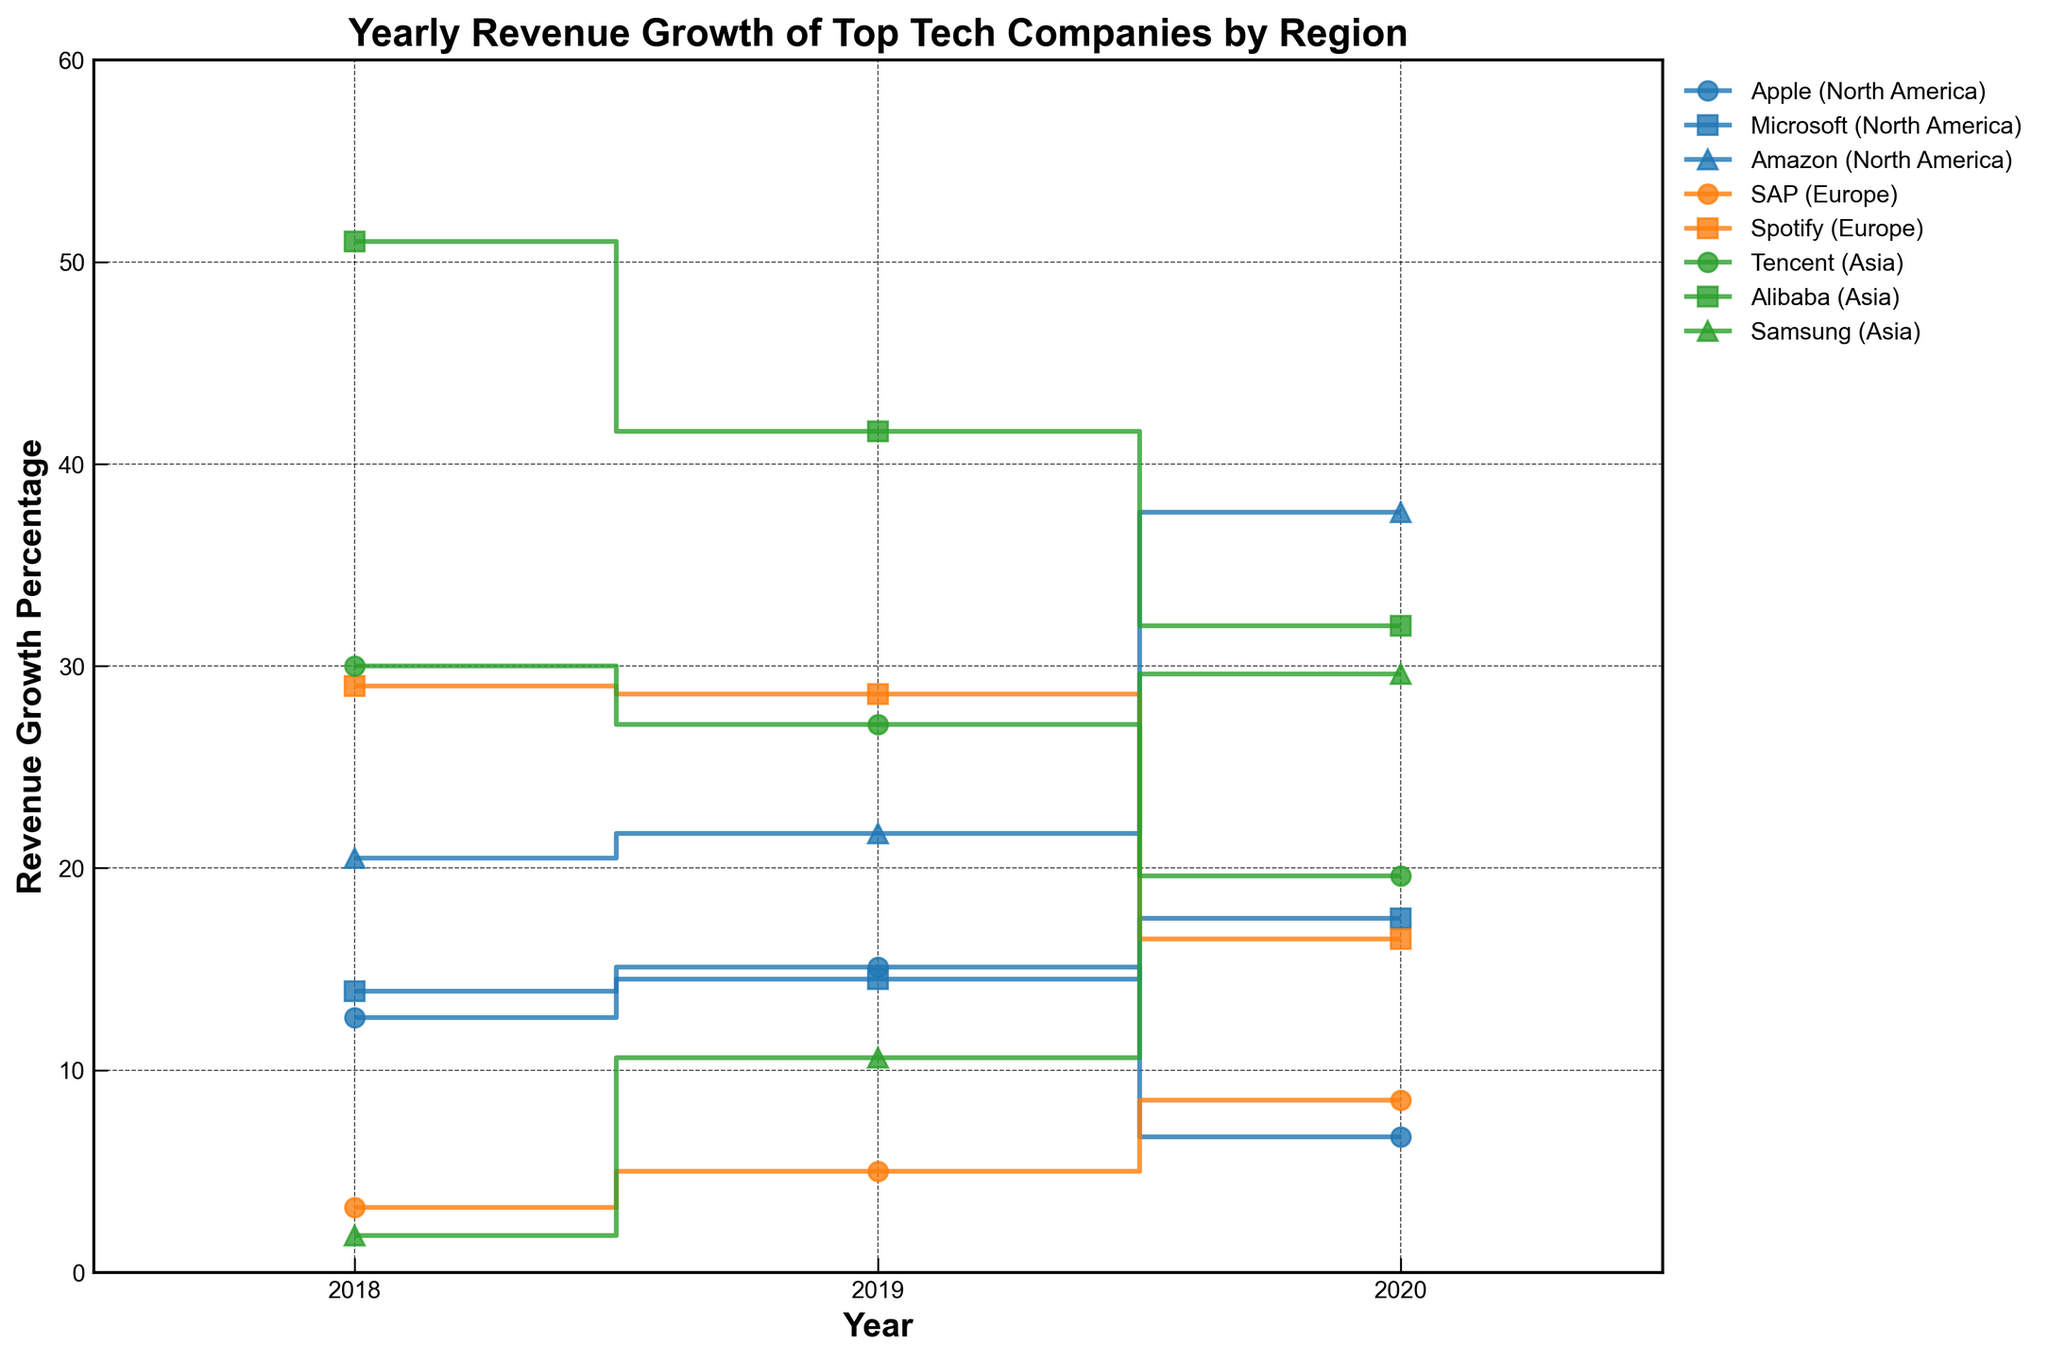What is the title of the figure? The title of the figure is located at the top center and is usually bold. It describes what the plot is about.
Answer: Yearly Revenue Growth of Top Tech Companies by Region Which company shows the highest revenue growth in 2020? To determine this, look at the end of each stair plot for 2020 and identify the highest point.
Answer: Amazon Which region has the company with the lowest revenue growth in 2018? Look at the stair plot for 2018 and identify the lowest point. Then, check the corresponding region.
Answer: Asia (Samsung, 1.8%) Which company had a continuous increase in revenue growth from 2018 to 2020? Check each stair plot for a company that has consecutive steps moving upwards from 2018 to 2020.
Answer: Microsoft What is the revenue growth percentage of Alibaba in 2019? Locate the stair plot for Alibaba and read the value for the year 2019.
Answer: 41.6% Which year did Apple experience a decrease in revenue growth? Find the stair plot for Apple and check for any step that goes downward. Look for the years around that drop.
Answer: 2020 How many companies are from Europe as shown in the plot? Identify the number of unique companies plotted under the "Europe" category.
Answer: 2 Comparing Spotify and SAP, which company had a higher growth rate in 2018 and by how much? Compare the revenue growth rate points for Spotify and SAP in 2018 and subtract the lower value from the higher value.
Answer: Spotify, by 25.8% Which company from Asia had the most significant drop in revenue growth from 2018 to 2019? Look at the stair plots of each Asian company between 2018 and 2019 and calculate the difference.
Answer: Alibaba What is the average revenue growth percentage of Microsoft from 2018 to 2020? Sum the revenue growth percentages of Microsoft for the years 2018, 2019, and 2020, and then divide by 3.
Answer: 15.3% 